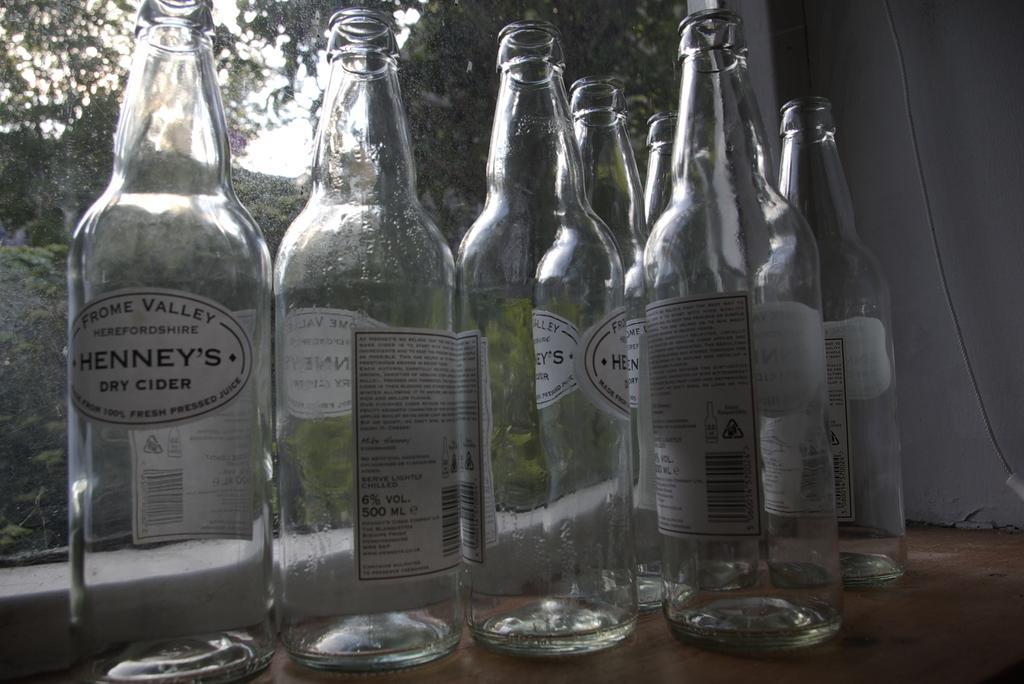In one or two sentences, can you explain what this image depicts? Some empty cider bottles are placed beside a window. 